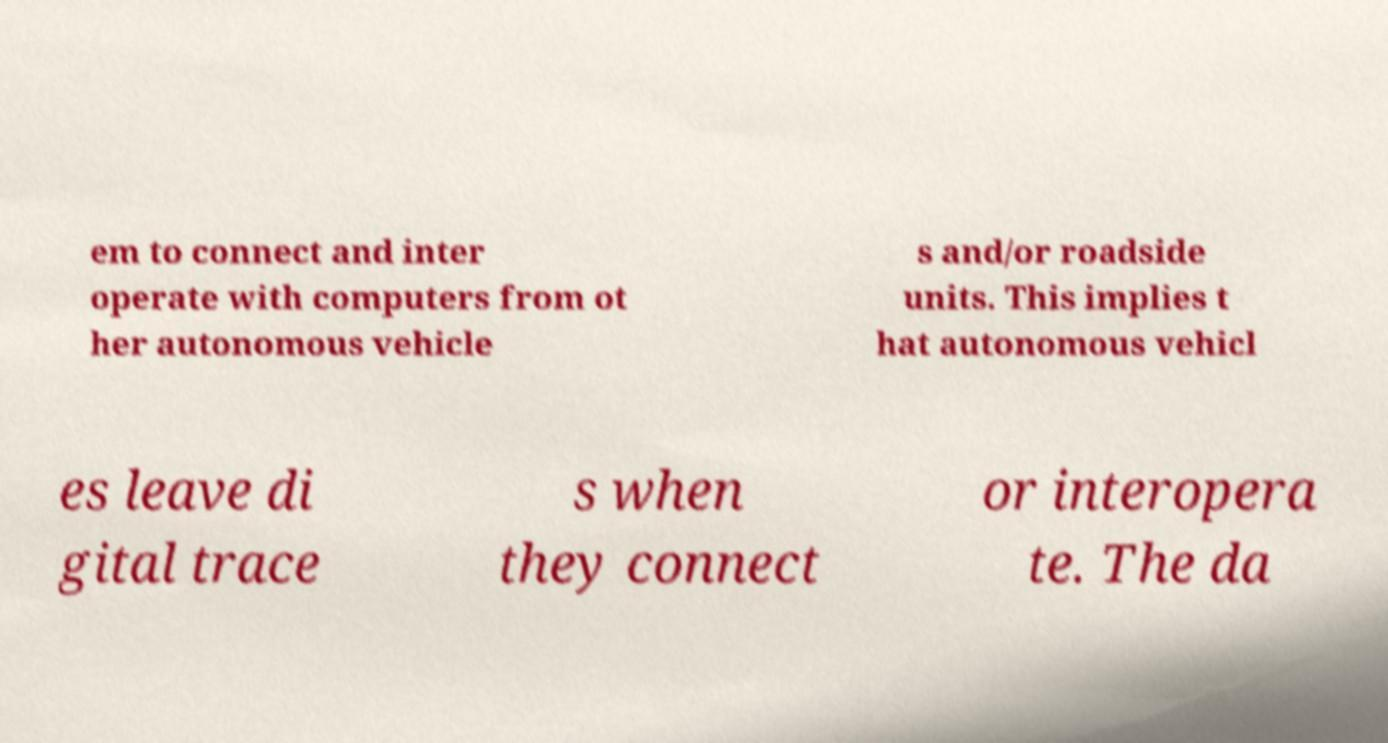Please read and relay the text visible in this image. What does it say? em to connect and inter operate with computers from ot her autonomous vehicle s and/or roadside units. This implies t hat autonomous vehicl es leave di gital trace s when they connect or interopera te. The da 